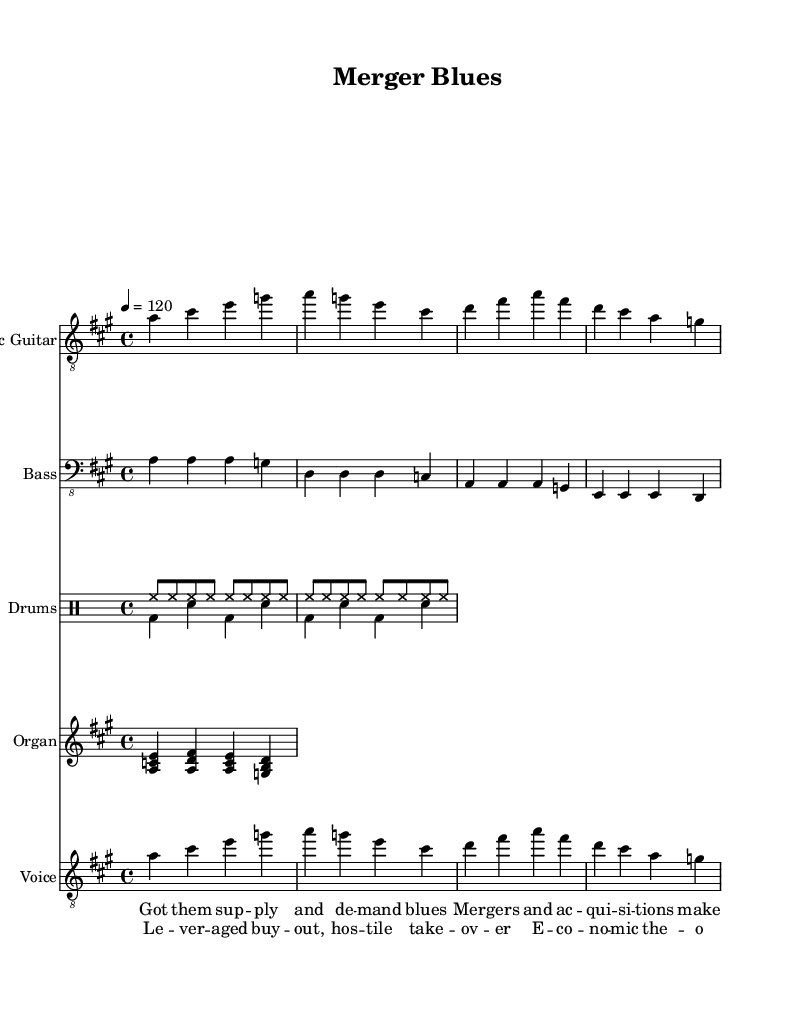What is the key signature of this music? The key signature is A major, which has three sharps (F#, C#, and G#). This is indicated at the beginning of the staff where the sharps are placed.
Answer: A major What is the time signature of this piece? The time signature shown at the beginning of the music is 4/4, meaning there are four beats in each measure and a quarter note gets one beat. This can be seen in the first part of the score.
Answer: 4/4 What is the tempo marking for this piece? The tempo marking is given as "4 = 120," indicating the tempo is quarter note equals 120 beats per minute, which is typical for upbeat electric blues songs.
Answer: 120 How many measures are there in the verse? The verse consists of two measures as seen from the notation under the vocal staff, each containing phrases that are set to the music. This can be counted directly from the measured notes.
Answer: 2 What is the chord structure of the organ riff? The organ riff consists of triadic chords including A major and G major in the first two bars, noticeable through the simultaneous note values played together in the staff.
Answer: A major and G major What economic concept is referenced in the lyrics of the chorus? The lyrics directly reference 'leveraged buyout' which is a financial term indicating a transaction that uses borrowed funds to meet the cost of acquisition. This concept is evident in the wording and context of the chorus.
Answer: Leveraged buyout What musical element distinguishes Electric Blues from other genres? The use of electric guitar riffs and a steady rhythm section is a distinct feature of Electric Blues, essential for creating its characteristic sound and groove, as clearly demonstrated in the score.
Answer: Electric guitar riffs 